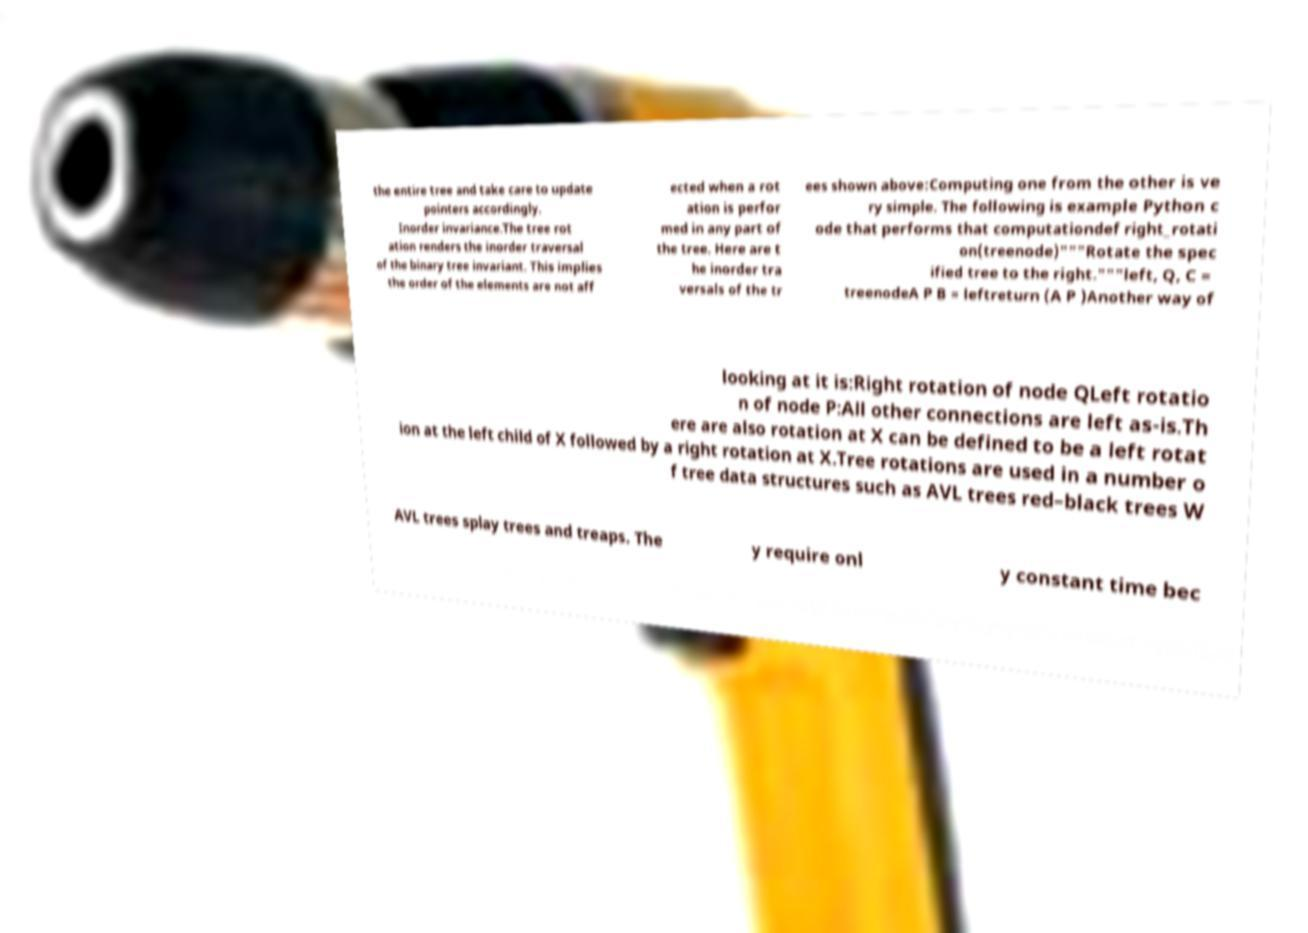What messages or text are displayed in this image? I need them in a readable, typed format. the entire tree and take care to update pointers accordingly. Inorder invariance.The tree rot ation renders the inorder traversal of the binary tree invariant. This implies the order of the elements are not aff ected when a rot ation is perfor med in any part of the tree. Here are t he inorder tra versals of the tr ees shown above:Computing one from the other is ve ry simple. The following is example Python c ode that performs that computationdef right_rotati on(treenode)"""Rotate the spec ified tree to the right."""left, Q, C = treenodeA P B = leftreturn (A P )Another way of looking at it is:Right rotation of node QLeft rotatio n of node P:All other connections are left as-is.Th ere are also rotation at X can be defined to be a left rotat ion at the left child of X followed by a right rotation at X.Tree rotations are used in a number o f tree data structures such as AVL trees red–black trees W AVL trees splay trees and treaps. The y require onl y constant time bec 